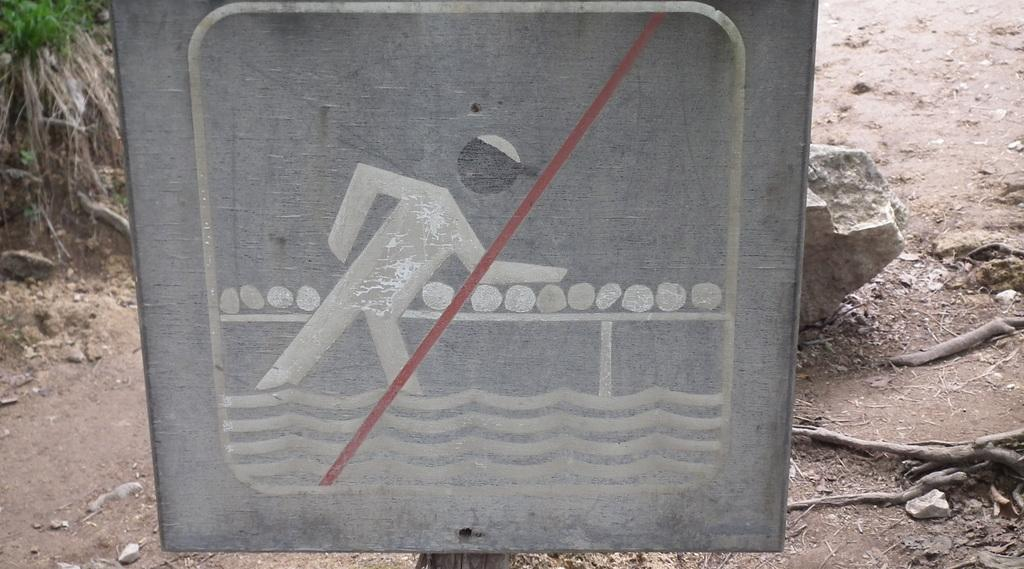What is the main purpose of the caution board in the image? The caution board in the image is related to a person entering water. What can be seen in the image besides the caution board? There is a stone visible in the image, as well as plants on the left side of the image. What type of beast is attacking the person in the image? There is no person or beast present in the image; it only features a caution board, a stone, and plants. 